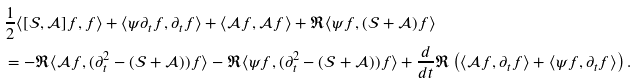Convert formula to latex. <formula><loc_0><loc_0><loc_500><loc_500>& \frac { 1 } { 2 } \langle [ \mathcal { S } , \mathcal { A } ] f , f \rangle + \langle \psi \partial _ { t } f , \partial _ { t } f \rangle + \langle \mathcal { A } f , \mathcal { A } f \rangle + \Re \langle \psi f , ( \mathcal { S } + \mathcal { A } ) f \rangle \\ & = - \Re \langle \mathcal { A } f , ( \partial _ { t } ^ { 2 } - ( \mathcal { S } + \mathcal { A } ) ) f \rangle - \Re \langle \psi f , ( \partial _ { t } ^ { 2 } - ( \mathcal { S } + \mathcal { A } ) ) f \rangle + \frac { d } { d t } \Re \left ( \langle \mathcal { A } f , \partial _ { t } f \rangle + \langle \psi f , \partial _ { t } f \rangle \right ) .</formula> 